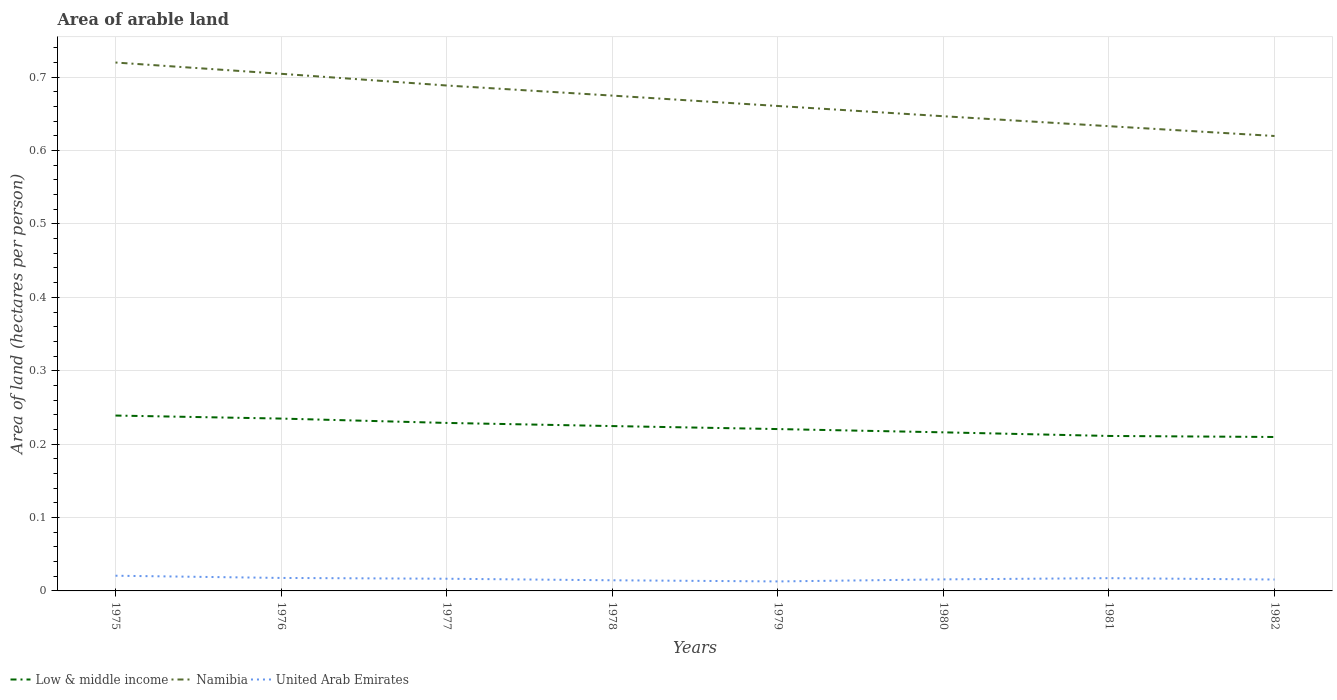How many different coloured lines are there?
Make the answer very short. 3. Does the line corresponding to Low & middle income intersect with the line corresponding to Namibia?
Offer a terse response. No. Is the number of lines equal to the number of legend labels?
Ensure brevity in your answer.  Yes. Across all years, what is the maximum total arable land in United Arab Emirates?
Your response must be concise. 0.01. In which year was the total arable land in Namibia maximum?
Offer a terse response. 1982. What is the total total arable land in United Arab Emirates in the graph?
Ensure brevity in your answer.  0. What is the difference between the highest and the second highest total arable land in Namibia?
Keep it short and to the point. 0.1. What is the difference between the highest and the lowest total arable land in United Arab Emirates?
Keep it short and to the point. 4. Is the total arable land in Low & middle income strictly greater than the total arable land in United Arab Emirates over the years?
Offer a terse response. No. What is the difference between two consecutive major ticks on the Y-axis?
Provide a short and direct response. 0.1. Does the graph contain any zero values?
Provide a short and direct response. No. Does the graph contain grids?
Your answer should be compact. Yes. What is the title of the graph?
Provide a short and direct response. Area of arable land. What is the label or title of the Y-axis?
Keep it short and to the point. Area of land (hectares per person). What is the Area of land (hectares per person) in Low & middle income in 1975?
Your response must be concise. 0.24. What is the Area of land (hectares per person) of Namibia in 1975?
Your answer should be very brief. 0.72. What is the Area of land (hectares per person) of United Arab Emirates in 1975?
Provide a succinct answer. 0.02. What is the Area of land (hectares per person) of Low & middle income in 1976?
Provide a succinct answer. 0.23. What is the Area of land (hectares per person) in Namibia in 1976?
Your response must be concise. 0.7. What is the Area of land (hectares per person) in United Arab Emirates in 1976?
Ensure brevity in your answer.  0.02. What is the Area of land (hectares per person) of Low & middle income in 1977?
Your answer should be very brief. 0.23. What is the Area of land (hectares per person) of Namibia in 1977?
Ensure brevity in your answer.  0.69. What is the Area of land (hectares per person) in United Arab Emirates in 1977?
Keep it short and to the point. 0.02. What is the Area of land (hectares per person) of Low & middle income in 1978?
Your answer should be very brief. 0.22. What is the Area of land (hectares per person) in Namibia in 1978?
Your response must be concise. 0.67. What is the Area of land (hectares per person) in United Arab Emirates in 1978?
Make the answer very short. 0.01. What is the Area of land (hectares per person) of Low & middle income in 1979?
Keep it short and to the point. 0.22. What is the Area of land (hectares per person) of Namibia in 1979?
Your answer should be very brief. 0.66. What is the Area of land (hectares per person) in United Arab Emirates in 1979?
Your answer should be very brief. 0.01. What is the Area of land (hectares per person) in Low & middle income in 1980?
Your answer should be compact. 0.22. What is the Area of land (hectares per person) in Namibia in 1980?
Make the answer very short. 0.65. What is the Area of land (hectares per person) of United Arab Emirates in 1980?
Your answer should be very brief. 0.02. What is the Area of land (hectares per person) of Low & middle income in 1981?
Keep it short and to the point. 0.21. What is the Area of land (hectares per person) in Namibia in 1981?
Offer a terse response. 0.63. What is the Area of land (hectares per person) in United Arab Emirates in 1981?
Ensure brevity in your answer.  0.02. What is the Area of land (hectares per person) of Low & middle income in 1982?
Make the answer very short. 0.21. What is the Area of land (hectares per person) in Namibia in 1982?
Your answer should be very brief. 0.62. What is the Area of land (hectares per person) in United Arab Emirates in 1982?
Make the answer very short. 0.02. Across all years, what is the maximum Area of land (hectares per person) in Low & middle income?
Your answer should be very brief. 0.24. Across all years, what is the maximum Area of land (hectares per person) of Namibia?
Make the answer very short. 0.72. Across all years, what is the maximum Area of land (hectares per person) in United Arab Emirates?
Your answer should be compact. 0.02. Across all years, what is the minimum Area of land (hectares per person) of Low & middle income?
Offer a very short reply. 0.21. Across all years, what is the minimum Area of land (hectares per person) of Namibia?
Ensure brevity in your answer.  0.62. Across all years, what is the minimum Area of land (hectares per person) of United Arab Emirates?
Offer a very short reply. 0.01. What is the total Area of land (hectares per person) in Low & middle income in the graph?
Ensure brevity in your answer.  1.78. What is the total Area of land (hectares per person) in Namibia in the graph?
Offer a terse response. 5.35. What is the total Area of land (hectares per person) of United Arab Emirates in the graph?
Ensure brevity in your answer.  0.13. What is the difference between the Area of land (hectares per person) in Low & middle income in 1975 and that in 1976?
Make the answer very short. 0. What is the difference between the Area of land (hectares per person) in Namibia in 1975 and that in 1976?
Your answer should be compact. 0.02. What is the difference between the Area of land (hectares per person) in United Arab Emirates in 1975 and that in 1976?
Offer a very short reply. 0. What is the difference between the Area of land (hectares per person) in Low & middle income in 1975 and that in 1977?
Your answer should be compact. 0.01. What is the difference between the Area of land (hectares per person) of Namibia in 1975 and that in 1977?
Keep it short and to the point. 0.03. What is the difference between the Area of land (hectares per person) in United Arab Emirates in 1975 and that in 1977?
Ensure brevity in your answer.  0. What is the difference between the Area of land (hectares per person) of Low & middle income in 1975 and that in 1978?
Your answer should be very brief. 0.01. What is the difference between the Area of land (hectares per person) in Namibia in 1975 and that in 1978?
Give a very brief answer. 0.05. What is the difference between the Area of land (hectares per person) of United Arab Emirates in 1975 and that in 1978?
Offer a very short reply. 0.01. What is the difference between the Area of land (hectares per person) in Low & middle income in 1975 and that in 1979?
Provide a short and direct response. 0.02. What is the difference between the Area of land (hectares per person) in Namibia in 1975 and that in 1979?
Ensure brevity in your answer.  0.06. What is the difference between the Area of land (hectares per person) of United Arab Emirates in 1975 and that in 1979?
Offer a very short reply. 0.01. What is the difference between the Area of land (hectares per person) in Low & middle income in 1975 and that in 1980?
Provide a short and direct response. 0.02. What is the difference between the Area of land (hectares per person) of Namibia in 1975 and that in 1980?
Provide a short and direct response. 0.07. What is the difference between the Area of land (hectares per person) in United Arab Emirates in 1975 and that in 1980?
Provide a short and direct response. 0.01. What is the difference between the Area of land (hectares per person) of Low & middle income in 1975 and that in 1981?
Make the answer very short. 0.03. What is the difference between the Area of land (hectares per person) in Namibia in 1975 and that in 1981?
Keep it short and to the point. 0.09. What is the difference between the Area of land (hectares per person) of United Arab Emirates in 1975 and that in 1981?
Offer a terse response. 0. What is the difference between the Area of land (hectares per person) in Low & middle income in 1975 and that in 1982?
Provide a short and direct response. 0.03. What is the difference between the Area of land (hectares per person) in Namibia in 1975 and that in 1982?
Give a very brief answer. 0.1. What is the difference between the Area of land (hectares per person) of United Arab Emirates in 1975 and that in 1982?
Provide a short and direct response. 0.01. What is the difference between the Area of land (hectares per person) of Low & middle income in 1976 and that in 1977?
Provide a short and direct response. 0.01. What is the difference between the Area of land (hectares per person) in Namibia in 1976 and that in 1977?
Ensure brevity in your answer.  0.02. What is the difference between the Area of land (hectares per person) of United Arab Emirates in 1976 and that in 1977?
Provide a succinct answer. 0. What is the difference between the Area of land (hectares per person) in Low & middle income in 1976 and that in 1978?
Offer a very short reply. 0.01. What is the difference between the Area of land (hectares per person) in Namibia in 1976 and that in 1978?
Keep it short and to the point. 0.03. What is the difference between the Area of land (hectares per person) of United Arab Emirates in 1976 and that in 1978?
Ensure brevity in your answer.  0. What is the difference between the Area of land (hectares per person) in Low & middle income in 1976 and that in 1979?
Keep it short and to the point. 0.01. What is the difference between the Area of land (hectares per person) in Namibia in 1976 and that in 1979?
Provide a succinct answer. 0.04. What is the difference between the Area of land (hectares per person) of United Arab Emirates in 1976 and that in 1979?
Offer a very short reply. 0. What is the difference between the Area of land (hectares per person) in Low & middle income in 1976 and that in 1980?
Your answer should be compact. 0.02. What is the difference between the Area of land (hectares per person) in Namibia in 1976 and that in 1980?
Your answer should be compact. 0.06. What is the difference between the Area of land (hectares per person) in United Arab Emirates in 1976 and that in 1980?
Ensure brevity in your answer.  0. What is the difference between the Area of land (hectares per person) of Low & middle income in 1976 and that in 1981?
Offer a terse response. 0.02. What is the difference between the Area of land (hectares per person) of Namibia in 1976 and that in 1981?
Make the answer very short. 0.07. What is the difference between the Area of land (hectares per person) of Low & middle income in 1976 and that in 1982?
Offer a very short reply. 0.03. What is the difference between the Area of land (hectares per person) of Namibia in 1976 and that in 1982?
Ensure brevity in your answer.  0.08. What is the difference between the Area of land (hectares per person) in United Arab Emirates in 1976 and that in 1982?
Make the answer very short. 0. What is the difference between the Area of land (hectares per person) of Low & middle income in 1977 and that in 1978?
Your response must be concise. 0. What is the difference between the Area of land (hectares per person) in Namibia in 1977 and that in 1978?
Offer a very short reply. 0.01. What is the difference between the Area of land (hectares per person) of United Arab Emirates in 1977 and that in 1978?
Your answer should be compact. 0. What is the difference between the Area of land (hectares per person) in Low & middle income in 1977 and that in 1979?
Your answer should be compact. 0.01. What is the difference between the Area of land (hectares per person) of Namibia in 1977 and that in 1979?
Your response must be concise. 0.03. What is the difference between the Area of land (hectares per person) of United Arab Emirates in 1977 and that in 1979?
Make the answer very short. 0. What is the difference between the Area of land (hectares per person) in Low & middle income in 1977 and that in 1980?
Your answer should be compact. 0.01. What is the difference between the Area of land (hectares per person) of Namibia in 1977 and that in 1980?
Your answer should be compact. 0.04. What is the difference between the Area of land (hectares per person) of United Arab Emirates in 1977 and that in 1980?
Provide a short and direct response. 0. What is the difference between the Area of land (hectares per person) of Low & middle income in 1977 and that in 1981?
Your response must be concise. 0.02. What is the difference between the Area of land (hectares per person) in Namibia in 1977 and that in 1981?
Your response must be concise. 0.06. What is the difference between the Area of land (hectares per person) in United Arab Emirates in 1977 and that in 1981?
Keep it short and to the point. -0. What is the difference between the Area of land (hectares per person) in Low & middle income in 1977 and that in 1982?
Ensure brevity in your answer.  0.02. What is the difference between the Area of land (hectares per person) of Namibia in 1977 and that in 1982?
Your answer should be very brief. 0.07. What is the difference between the Area of land (hectares per person) in United Arab Emirates in 1977 and that in 1982?
Your answer should be very brief. 0. What is the difference between the Area of land (hectares per person) in Low & middle income in 1978 and that in 1979?
Your response must be concise. 0. What is the difference between the Area of land (hectares per person) of Namibia in 1978 and that in 1979?
Your answer should be compact. 0.01. What is the difference between the Area of land (hectares per person) of United Arab Emirates in 1978 and that in 1979?
Make the answer very short. 0. What is the difference between the Area of land (hectares per person) of Low & middle income in 1978 and that in 1980?
Your response must be concise. 0.01. What is the difference between the Area of land (hectares per person) in Namibia in 1978 and that in 1980?
Ensure brevity in your answer.  0.03. What is the difference between the Area of land (hectares per person) in United Arab Emirates in 1978 and that in 1980?
Offer a very short reply. -0. What is the difference between the Area of land (hectares per person) of Low & middle income in 1978 and that in 1981?
Your answer should be compact. 0.01. What is the difference between the Area of land (hectares per person) in Namibia in 1978 and that in 1981?
Keep it short and to the point. 0.04. What is the difference between the Area of land (hectares per person) in United Arab Emirates in 1978 and that in 1981?
Provide a short and direct response. -0. What is the difference between the Area of land (hectares per person) of Low & middle income in 1978 and that in 1982?
Provide a succinct answer. 0.01. What is the difference between the Area of land (hectares per person) in Namibia in 1978 and that in 1982?
Your answer should be compact. 0.06. What is the difference between the Area of land (hectares per person) in United Arab Emirates in 1978 and that in 1982?
Ensure brevity in your answer.  -0. What is the difference between the Area of land (hectares per person) of Low & middle income in 1979 and that in 1980?
Give a very brief answer. 0. What is the difference between the Area of land (hectares per person) of Namibia in 1979 and that in 1980?
Ensure brevity in your answer.  0.01. What is the difference between the Area of land (hectares per person) in United Arab Emirates in 1979 and that in 1980?
Your answer should be very brief. -0. What is the difference between the Area of land (hectares per person) in Low & middle income in 1979 and that in 1981?
Ensure brevity in your answer.  0.01. What is the difference between the Area of land (hectares per person) of Namibia in 1979 and that in 1981?
Provide a succinct answer. 0.03. What is the difference between the Area of land (hectares per person) in United Arab Emirates in 1979 and that in 1981?
Offer a very short reply. -0. What is the difference between the Area of land (hectares per person) of Low & middle income in 1979 and that in 1982?
Offer a very short reply. 0.01. What is the difference between the Area of land (hectares per person) of Namibia in 1979 and that in 1982?
Your answer should be very brief. 0.04. What is the difference between the Area of land (hectares per person) in United Arab Emirates in 1979 and that in 1982?
Offer a very short reply. -0. What is the difference between the Area of land (hectares per person) in Low & middle income in 1980 and that in 1981?
Your answer should be very brief. 0. What is the difference between the Area of land (hectares per person) of Namibia in 1980 and that in 1981?
Offer a terse response. 0.01. What is the difference between the Area of land (hectares per person) in United Arab Emirates in 1980 and that in 1981?
Ensure brevity in your answer.  -0. What is the difference between the Area of land (hectares per person) in Low & middle income in 1980 and that in 1982?
Ensure brevity in your answer.  0.01. What is the difference between the Area of land (hectares per person) in Namibia in 1980 and that in 1982?
Your answer should be compact. 0.03. What is the difference between the Area of land (hectares per person) in Low & middle income in 1981 and that in 1982?
Provide a short and direct response. 0. What is the difference between the Area of land (hectares per person) in Namibia in 1981 and that in 1982?
Provide a short and direct response. 0.01. What is the difference between the Area of land (hectares per person) in United Arab Emirates in 1981 and that in 1982?
Keep it short and to the point. 0. What is the difference between the Area of land (hectares per person) in Low & middle income in 1975 and the Area of land (hectares per person) in Namibia in 1976?
Your answer should be compact. -0.47. What is the difference between the Area of land (hectares per person) of Low & middle income in 1975 and the Area of land (hectares per person) of United Arab Emirates in 1976?
Your answer should be very brief. 0.22. What is the difference between the Area of land (hectares per person) of Namibia in 1975 and the Area of land (hectares per person) of United Arab Emirates in 1976?
Ensure brevity in your answer.  0.7. What is the difference between the Area of land (hectares per person) of Low & middle income in 1975 and the Area of land (hectares per person) of Namibia in 1977?
Your answer should be compact. -0.45. What is the difference between the Area of land (hectares per person) in Low & middle income in 1975 and the Area of land (hectares per person) in United Arab Emirates in 1977?
Offer a very short reply. 0.22. What is the difference between the Area of land (hectares per person) in Namibia in 1975 and the Area of land (hectares per person) in United Arab Emirates in 1977?
Make the answer very short. 0.7. What is the difference between the Area of land (hectares per person) of Low & middle income in 1975 and the Area of land (hectares per person) of Namibia in 1978?
Give a very brief answer. -0.44. What is the difference between the Area of land (hectares per person) of Low & middle income in 1975 and the Area of land (hectares per person) of United Arab Emirates in 1978?
Your response must be concise. 0.22. What is the difference between the Area of land (hectares per person) in Namibia in 1975 and the Area of land (hectares per person) in United Arab Emirates in 1978?
Your answer should be very brief. 0.71. What is the difference between the Area of land (hectares per person) in Low & middle income in 1975 and the Area of land (hectares per person) in Namibia in 1979?
Your answer should be very brief. -0.42. What is the difference between the Area of land (hectares per person) in Low & middle income in 1975 and the Area of land (hectares per person) in United Arab Emirates in 1979?
Your answer should be compact. 0.23. What is the difference between the Area of land (hectares per person) of Namibia in 1975 and the Area of land (hectares per person) of United Arab Emirates in 1979?
Provide a succinct answer. 0.71. What is the difference between the Area of land (hectares per person) of Low & middle income in 1975 and the Area of land (hectares per person) of Namibia in 1980?
Provide a succinct answer. -0.41. What is the difference between the Area of land (hectares per person) of Low & middle income in 1975 and the Area of land (hectares per person) of United Arab Emirates in 1980?
Offer a very short reply. 0.22. What is the difference between the Area of land (hectares per person) of Namibia in 1975 and the Area of land (hectares per person) of United Arab Emirates in 1980?
Make the answer very short. 0.7. What is the difference between the Area of land (hectares per person) of Low & middle income in 1975 and the Area of land (hectares per person) of Namibia in 1981?
Your answer should be very brief. -0.39. What is the difference between the Area of land (hectares per person) in Low & middle income in 1975 and the Area of land (hectares per person) in United Arab Emirates in 1981?
Offer a very short reply. 0.22. What is the difference between the Area of land (hectares per person) of Namibia in 1975 and the Area of land (hectares per person) of United Arab Emirates in 1981?
Give a very brief answer. 0.7. What is the difference between the Area of land (hectares per person) in Low & middle income in 1975 and the Area of land (hectares per person) in Namibia in 1982?
Provide a succinct answer. -0.38. What is the difference between the Area of land (hectares per person) of Low & middle income in 1975 and the Area of land (hectares per person) of United Arab Emirates in 1982?
Your answer should be compact. 0.22. What is the difference between the Area of land (hectares per person) of Namibia in 1975 and the Area of land (hectares per person) of United Arab Emirates in 1982?
Your answer should be very brief. 0.7. What is the difference between the Area of land (hectares per person) in Low & middle income in 1976 and the Area of land (hectares per person) in Namibia in 1977?
Your answer should be very brief. -0.45. What is the difference between the Area of land (hectares per person) of Low & middle income in 1976 and the Area of land (hectares per person) of United Arab Emirates in 1977?
Your answer should be compact. 0.22. What is the difference between the Area of land (hectares per person) in Namibia in 1976 and the Area of land (hectares per person) in United Arab Emirates in 1977?
Give a very brief answer. 0.69. What is the difference between the Area of land (hectares per person) in Low & middle income in 1976 and the Area of land (hectares per person) in Namibia in 1978?
Your answer should be very brief. -0.44. What is the difference between the Area of land (hectares per person) of Low & middle income in 1976 and the Area of land (hectares per person) of United Arab Emirates in 1978?
Offer a terse response. 0.22. What is the difference between the Area of land (hectares per person) in Namibia in 1976 and the Area of land (hectares per person) in United Arab Emirates in 1978?
Keep it short and to the point. 0.69. What is the difference between the Area of land (hectares per person) in Low & middle income in 1976 and the Area of land (hectares per person) in Namibia in 1979?
Offer a terse response. -0.43. What is the difference between the Area of land (hectares per person) in Low & middle income in 1976 and the Area of land (hectares per person) in United Arab Emirates in 1979?
Your response must be concise. 0.22. What is the difference between the Area of land (hectares per person) of Namibia in 1976 and the Area of land (hectares per person) of United Arab Emirates in 1979?
Keep it short and to the point. 0.69. What is the difference between the Area of land (hectares per person) in Low & middle income in 1976 and the Area of land (hectares per person) in Namibia in 1980?
Offer a terse response. -0.41. What is the difference between the Area of land (hectares per person) in Low & middle income in 1976 and the Area of land (hectares per person) in United Arab Emirates in 1980?
Offer a terse response. 0.22. What is the difference between the Area of land (hectares per person) in Namibia in 1976 and the Area of land (hectares per person) in United Arab Emirates in 1980?
Ensure brevity in your answer.  0.69. What is the difference between the Area of land (hectares per person) of Low & middle income in 1976 and the Area of land (hectares per person) of Namibia in 1981?
Your answer should be compact. -0.4. What is the difference between the Area of land (hectares per person) in Low & middle income in 1976 and the Area of land (hectares per person) in United Arab Emirates in 1981?
Give a very brief answer. 0.22. What is the difference between the Area of land (hectares per person) in Namibia in 1976 and the Area of land (hectares per person) in United Arab Emirates in 1981?
Give a very brief answer. 0.69. What is the difference between the Area of land (hectares per person) of Low & middle income in 1976 and the Area of land (hectares per person) of Namibia in 1982?
Your response must be concise. -0.39. What is the difference between the Area of land (hectares per person) in Low & middle income in 1976 and the Area of land (hectares per person) in United Arab Emirates in 1982?
Your answer should be compact. 0.22. What is the difference between the Area of land (hectares per person) of Namibia in 1976 and the Area of land (hectares per person) of United Arab Emirates in 1982?
Offer a terse response. 0.69. What is the difference between the Area of land (hectares per person) of Low & middle income in 1977 and the Area of land (hectares per person) of Namibia in 1978?
Keep it short and to the point. -0.45. What is the difference between the Area of land (hectares per person) of Low & middle income in 1977 and the Area of land (hectares per person) of United Arab Emirates in 1978?
Provide a succinct answer. 0.21. What is the difference between the Area of land (hectares per person) of Namibia in 1977 and the Area of land (hectares per person) of United Arab Emirates in 1978?
Ensure brevity in your answer.  0.67. What is the difference between the Area of land (hectares per person) of Low & middle income in 1977 and the Area of land (hectares per person) of Namibia in 1979?
Give a very brief answer. -0.43. What is the difference between the Area of land (hectares per person) of Low & middle income in 1977 and the Area of land (hectares per person) of United Arab Emirates in 1979?
Offer a terse response. 0.22. What is the difference between the Area of land (hectares per person) of Namibia in 1977 and the Area of land (hectares per person) of United Arab Emirates in 1979?
Ensure brevity in your answer.  0.68. What is the difference between the Area of land (hectares per person) in Low & middle income in 1977 and the Area of land (hectares per person) in Namibia in 1980?
Offer a very short reply. -0.42. What is the difference between the Area of land (hectares per person) in Low & middle income in 1977 and the Area of land (hectares per person) in United Arab Emirates in 1980?
Your response must be concise. 0.21. What is the difference between the Area of land (hectares per person) of Namibia in 1977 and the Area of land (hectares per person) of United Arab Emirates in 1980?
Your response must be concise. 0.67. What is the difference between the Area of land (hectares per person) of Low & middle income in 1977 and the Area of land (hectares per person) of Namibia in 1981?
Offer a very short reply. -0.4. What is the difference between the Area of land (hectares per person) in Low & middle income in 1977 and the Area of land (hectares per person) in United Arab Emirates in 1981?
Provide a succinct answer. 0.21. What is the difference between the Area of land (hectares per person) of Namibia in 1977 and the Area of land (hectares per person) of United Arab Emirates in 1981?
Offer a terse response. 0.67. What is the difference between the Area of land (hectares per person) in Low & middle income in 1977 and the Area of land (hectares per person) in Namibia in 1982?
Provide a succinct answer. -0.39. What is the difference between the Area of land (hectares per person) of Low & middle income in 1977 and the Area of land (hectares per person) of United Arab Emirates in 1982?
Give a very brief answer. 0.21. What is the difference between the Area of land (hectares per person) in Namibia in 1977 and the Area of land (hectares per person) in United Arab Emirates in 1982?
Give a very brief answer. 0.67. What is the difference between the Area of land (hectares per person) in Low & middle income in 1978 and the Area of land (hectares per person) in Namibia in 1979?
Make the answer very short. -0.44. What is the difference between the Area of land (hectares per person) of Low & middle income in 1978 and the Area of land (hectares per person) of United Arab Emirates in 1979?
Make the answer very short. 0.21. What is the difference between the Area of land (hectares per person) of Namibia in 1978 and the Area of land (hectares per person) of United Arab Emirates in 1979?
Make the answer very short. 0.66. What is the difference between the Area of land (hectares per person) in Low & middle income in 1978 and the Area of land (hectares per person) in Namibia in 1980?
Your answer should be compact. -0.42. What is the difference between the Area of land (hectares per person) in Low & middle income in 1978 and the Area of land (hectares per person) in United Arab Emirates in 1980?
Offer a very short reply. 0.21. What is the difference between the Area of land (hectares per person) of Namibia in 1978 and the Area of land (hectares per person) of United Arab Emirates in 1980?
Your response must be concise. 0.66. What is the difference between the Area of land (hectares per person) of Low & middle income in 1978 and the Area of land (hectares per person) of Namibia in 1981?
Your answer should be compact. -0.41. What is the difference between the Area of land (hectares per person) of Low & middle income in 1978 and the Area of land (hectares per person) of United Arab Emirates in 1981?
Ensure brevity in your answer.  0.21. What is the difference between the Area of land (hectares per person) in Namibia in 1978 and the Area of land (hectares per person) in United Arab Emirates in 1981?
Keep it short and to the point. 0.66. What is the difference between the Area of land (hectares per person) of Low & middle income in 1978 and the Area of land (hectares per person) of Namibia in 1982?
Your answer should be compact. -0.4. What is the difference between the Area of land (hectares per person) in Low & middle income in 1978 and the Area of land (hectares per person) in United Arab Emirates in 1982?
Provide a short and direct response. 0.21. What is the difference between the Area of land (hectares per person) in Namibia in 1978 and the Area of land (hectares per person) in United Arab Emirates in 1982?
Offer a terse response. 0.66. What is the difference between the Area of land (hectares per person) in Low & middle income in 1979 and the Area of land (hectares per person) in Namibia in 1980?
Your response must be concise. -0.43. What is the difference between the Area of land (hectares per person) of Low & middle income in 1979 and the Area of land (hectares per person) of United Arab Emirates in 1980?
Offer a very short reply. 0.2. What is the difference between the Area of land (hectares per person) of Namibia in 1979 and the Area of land (hectares per person) of United Arab Emirates in 1980?
Keep it short and to the point. 0.65. What is the difference between the Area of land (hectares per person) in Low & middle income in 1979 and the Area of land (hectares per person) in Namibia in 1981?
Your response must be concise. -0.41. What is the difference between the Area of land (hectares per person) of Low & middle income in 1979 and the Area of land (hectares per person) of United Arab Emirates in 1981?
Keep it short and to the point. 0.2. What is the difference between the Area of land (hectares per person) in Namibia in 1979 and the Area of land (hectares per person) in United Arab Emirates in 1981?
Your answer should be very brief. 0.64. What is the difference between the Area of land (hectares per person) of Low & middle income in 1979 and the Area of land (hectares per person) of Namibia in 1982?
Offer a terse response. -0.4. What is the difference between the Area of land (hectares per person) of Low & middle income in 1979 and the Area of land (hectares per person) of United Arab Emirates in 1982?
Give a very brief answer. 0.2. What is the difference between the Area of land (hectares per person) of Namibia in 1979 and the Area of land (hectares per person) of United Arab Emirates in 1982?
Your response must be concise. 0.65. What is the difference between the Area of land (hectares per person) in Low & middle income in 1980 and the Area of land (hectares per person) in Namibia in 1981?
Give a very brief answer. -0.42. What is the difference between the Area of land (hectares per person) of Low & middle income in 1980 and the Area of land (hectares per person) of United Arab Emirates in 1981?
Offer a terse response. 0.2. What is the difference between the Area of land (hectares per person) in Namibia in 1980 and the Area of land (hectares per person) in United Arab Emirates in 1981?
Provide a succinct answer. 0.63. What is the difference between the Area of land (hectares per person) in Low & middle income in 1980 and the Area of land (hectares per person) in Namibia in 1982?
Offer a very short reply. -0.4. What is the difference between the Area of land (hectares per person) of Low & middle income in 1980 and the Area of land (hectares per person) of United Arab Emirates in 1982?
Offer a terse response. 0.2. What is the difference between the Area of land (hectares per person) of Namibia in 1980 and the Area of land (hectares per person) of United Arab Emirates in 1982?
Offer a very short reply. 0.63. What is the difference between the Area of land (hectares per person) in Low & middle income in 1981 and the Area of land (hectares per person) in Namibia in 1982?
Offer a terse response. -0.41. What is the difference between the Area of land (hectares per person) of Low & middle income in 1981 and the Area of land (hectares per person) of United Arab Emirates in 1982?
Your answer should be very brief. 0.2. What is the difference between the Area of land (hectares per person) of Namibia in 1981 and the Area of land (hectares per person) of United Arab Emirates in 1982?
Make the answer very short. 0.62. What is the average Area of land (hectares per person) in Low & middle income per year?
Your answer should be compact. 0.22. What is the average Area of land (hectares per person) of Namibia per year?
Make the answer very short. 0.67. What is the average Area of land (hectares per person) of United Arab Emirates per year?
Offer a very short reply. 0.02. In the year 1975, what is the difference between the Area of land (hectares per person) in Low & middle income and Area of land (hectares per person) in Namibia?
Offer a terse response. -0.48. In the year 1975, what is the difference between the Area of land (hectares per person) of Low & middle income and Area of land (hectares per person) of United Arab Emirates?
Your answer should be very brief. 0.22. In the year 1975, what is the difference between the Area of land (hectares per person) of Namibia and Area of land (hectares per person) of United Arab Emirates?
Make the answer very short. 0.7. In the year 1976, what is the difference between the Area of land (hectares per person) in Low & middle income and Area of land (hectares per person) in Namibia?
Make the answer very short. -0.47. In the year 1976, what is the difference between the Area of land (hectares per person) in Low & middle income and Area of land (hectares per person) in United Arab Emirates?
Your response must be concise. 0.22. In the year 1976, what is the difference between the Area of land (hectares per person) in Namibia and Area of land (hectares per person) in United Arab Emirates?
Your answer should be compact. 0.69. In the year 1977, what is the difference between the Area of land (hectares per person) of Low & middle income and Area of land (hectares per person) of Namibia?
Your response must be concise. -0.46. In the year 1977, what is the difference between the Area of land (hectares per person) of Low & middle income and Area of land (hectares per person) of United Arab Emirates?
Keep it short and to the point. 0.21. In the year 1977, what is the difference between the Area of land (hectares per person) of Namibia and Area of land (hectares per person) of United Arab Emirates?
Your response must be concise. 0.67. In the year 1978, what is the difference between the Area of land (hectares per person) in Low & middle income and Area of land (hectares per person) in Namibia?
Your response must be concise. -0.45. In the year 1978, what is the difference between the Area of land (hectares per person) of Low & middle income and Area of land (hectares per person) of United Arab Emirates?
Keep it short and to the point. 0.21. In the year 1978, what is the difference between the Area of land (hectares per person) of Namibia and Area of land (hectares per person) of United Arab Emirates?
Your answer should be very brief. 0.66. In the year 1979, what is the difference between the Area of land (hectares per person) in Low & middle income and Area of land (hectares per person) in Namibia?
Give a very brief answer. -0.44. In the year 1979, what is the difference between the Area of land (hectares per person) of Low & middle income and Area of land (hectares per person) of United Arab Emirates?
Your response must be concise. 0.21. In the year 1979, what is the difference between the Area of land (hectares per person) in Namibia and Area of land (hectares per person) in United Arab Emirates?
Your answer should be very brief. 0.65. In the year 1980, what is the difference between the Area of land (hectares per person) in Low & middle income and Area of land (hectares per person) in Namibia?
Ensure brevity in your answer.  -0.43. In the year 1980, what is the difference between the Area of land (hectares per person) of Low & middle income and Area of land (hectares per person) of United Arab Emirates?
Offer a very short reply. 0.2. In the year 1980, what is the difference between the Area of land (hectares per person) of Namibia and Area of land (hectares per person) of United Arab Emirates?
Make the answer very short. 0.63. In the year 1981, what is the difference between the Area of land (hectares per person) in Low & middle income and Area of land (hectares per person) in Namibia?
Ensure brevity in your answer.  -0.42. In the year 1981, what is the difference between the Area of land (hectares per person) in Low & middle income and Area of land (hectares per person) in United Arab Emirates?
Keep it short and to the point. 0.19. In the year 1981, what is the difference between the Area of land (hectares per person) in Namibia and Area of land (hectares per person) in United Arab Emirates?
Your answer should be very brief. 0.62. In the year 1982, what is the difference between the Area of land (hectares per person) in Low & middle income and Area of land (hectares per person) in Namibia?
Keep it short and to the point. -0.41. In the year 1982, what is the difference between the Area of land (hectares per person) of Low & middle income and Area of land (hectares per person) of United Arab Emirates?
Your answer should be compact. 0.19. In the year 1982, what is the difference between the Area of land (hectares per person) in Namibia and Area of land (hectares per person) in United Arab Emirates?
Make the answer very short. 0.6. What is the ratio of the Area of land (hectares per person) of Low & middle income in 1975 to that in 1976?
Make the answer very short. 1.02. What is the ratio of the Area of land (hectares per person) in Namibia in 1975 to that in 1976?
Provide a succinct answer. 1.02. What is the ratio of the Area of land (hectares per person) of United Arab Emirates in 1975 to that in 1976?
Offer a very short reply. 1.17. What is the ratio of the Area of land (hectares per person) in Low & middle income in 1975 to that in 1977?
Offer a very short reply. 1.04. What is the ratio of the Area of land (hectares per person) of Namibia in 1975 to that in 1977?
Provide a succinct answer. 1.05. What is the ratio of the Area of land (hectares per person) of United Arab Emirates in 1975 to that in 1977?
Give a very brief answer. 1.25. What is the ratio of the Area of land (hectares per person) in Low & middle income in 1975 to that in 1978?
Keep it short and to the point. 1.06. What is the ratio of the Area of land (hectares per person) in Namibia in 1975 to that in 1978?
Offer a very short reply. 1.07. What is the ratio of the Area of land (hectares per person) of United Arab Emirates in 1975 to that in 1978?
Ensure brevity in your answer.  1.43. What is the ratio of the Area of land (hectares per person) in Low & middle income in 1975 to that in 1979?
Your response must be concise. 1.08. What is the ratio of the Area of land (hectares per person) in Namibia in 1975 to that in 1979?
Your response must be concise. 1.09. What is the ratio of the Area of land (hectares per person) of Low & middle income in 1975 to that in 1980?
Your answer should be very brief. 1.11. What is the ratio of the Area of land (hectares per person) in Namibia in 1975 to that in 1980?
Give a very brief answer. 1.11. What is the ratio of the Area of land (hectares per person) of United Arab Emirates in 1975 to that in 1980?
Keep it short and to the point. 1.32. What is the ratio of the Area of land (hectares per person) in Low & middle income in 1975 to that in 1981?
Keep it short and to the point. 1.13. What is the ratio of the Area of land (hectares per person) of Namibia in 1975 to that in 1981?
Offer a terse response. 1.14. What is the ratio of the Area of land (hectares per person) of United Arab Emirates in 1975 to that in 1981?
Offer a very short reply. 1.19. What is the ratio of the Area of land (hectares per person) in Low & middle income in 1975 to that in 1982?
Ensure brevity in your answer.  1.14. What is the ratio of the Area of land (hectares per person) in Namibia in 1975 to that in 1982?
Keep it short and to the point. 1.16. What is the ratio of the Area of land (hectares per person) of United Arab Emirates in 1975 to that in 1982?
Make the answer very short. 1.33. What is the ratio of the Area of land (hectares per person) in Low & middle income in 1976 to that in 1977?
Keep it short and to the point. 1.03. What is the ratio of the Area of land (hectares per person) in Namibia in 1976 to that in 1977?
Offer a terse response. 1.02. What is the ratio of the Area of land (hectares per person) in United Arab Emirates in 1976 to that in 1977?
Offer a very short reply. 1.07. What is the ratio of the Area of land (hectares per person) in Low & middle income in 1976 to that in 1978?
Keep it short and to the point. 1.05. What is the ratio of the Area of land (hectares per person) in Namibia in 1976 to that in 1978?
Your response must be concise. 1.04. What is the ratio of the Area of land (hectares per person) in United Arab Emirates in 1976 to that in 1978?
Offer a terse response. 1.22. What is the ratio of the Area of land (hectares per person) in Low & middle income in 1976 to that in 1979?
Give a very brief answer. 1.06. What is the ratio of the Area of land (hectares per person) of Namibia in 1976 to that in 1979?
Provide a succinct answer. 1.07. What is the ratio of the Area of land (hectares per person) in United Arab Emirates in 1976 to that in 1979?
Your answer should be very brief. 1.37. What is the ratio of the Area of land (hectares per person) in Low & middle income in 1976 to that in 1980?
Your response must be concise. 1.09. What is the ratio of the Area of land (hectares per person) of Namibia in 1976 to that in 1980?
Ensure brevity in your answer.  1.09. What is the ratio of the Area of land (hectares per person) of United Arab Emirates in 1976 to that in 1980?
Offer a very short reply. 1.12. What is the ratio of the Area of land (hectares per person) in Low & middle income in 1976 to that in 1981?
Your answer should be compact. 1.11. What is the ratio of the Area of land (hectares per person) in Namibia in 1976 to that in 1981?
Provide a succinct answer. 1.11. What is the ratio of the Area of land (hectares per person) of United Arab Emirates in 1976 to that in 1981?
Offer a very short reply. 1.02. What is the ratio of the Area of land (hectares per person) of Low & middle income in 1976 to that in 1982?
Offer a terse response. 1.12. What is the ratio of the Area of land (hectares per person) in Namibia in 1976 to that in 1982?
Offer a very short reply. 1.14. What is the ratio of the Area of land (hectares per person) of United Arab Emirates in 1976 to that in 1982?
Keep it short and to the point. 1.14. What is the ratio of the Area of land (hectares per person) of Low & middle income in 1977 to that in 1978?
Keep it short and to the point. 1.02. What is the ratio of the Area of land (hectares per person) of Namibia in 1977 to that in 1978?
Offer a very short reply. 1.02. What is the ratio of the Area of land (hectares per person) of United Arab Emirates in 1977 to that in 1978?
Provide a short and direct response. 1.14. What is the ratio of the Area of land (hectares per person) in Low & middle income in 1977 to that in 1979?
Your answer should be very brief. 1.04. What is the ratio of the Area of land (hectares per person) of Namibia in 1977 to that in 1979?
Your answer should be very brief. 1.04. What is the ratio of the Area of land (hectares per person) in United Arab Emirates in 1977 to that in 1979?
Keep it short and to the point. 1.28. What is the ratio of the Area of land (hectares per person) in Low & middle income in 1977 to that in 1980?
Offer a terse response. 1.06. What is the ratio of the Area of land (hectares per person) of Namibia in 1977 to that in 1980?
Offer a terse response. 1.06. What is the ratio of the Area of land (hectares per person) of United Arab Emirates in 1977 to that in 1980?
Offer a very short reply. 1.05. What is the ratio of the Area of land (hectares per person) of Low & middle income in 1977 to that in 1981?
Keep it short and to the point. 1.08. What is the ratio of the Area of land (hectares per person) in Namibia in 1977 to that in 1981?
Your answer should be very brief. 1.09. What is the ratio of the Area of land (hectares per person) of United Arab Emirates in 1977 to that in 1981?
Give a very brief answer. 0.96. What is the ratio of the Area of land (hectares per person) in Low & middle income in 1977 to that in 1982?
Keep it short and to the point. 1.09. What is the ratio of the Area of land (hectares per person) of Namibia in 1977 to that in 1982?
Your response must be concise. 1.11. What is the ratio of the Area of land (hectares per person) of United Arab Emirates in 1977 to that in 1982?
Provide a short and direct response. 1.07. What is the ratio of the Area of land (hectares per person) of Low & middle income in 1978 to that in 1979?
Your response must be concise. 1.02. What is the ratio of the Area of land (hectares per person) of Namibia in 1978 to that in 1979?
Offer a terse response. 1.02. What is the ratio of the Area of land (hectares per person) of United Arab Emirates in 1978 to that in 1979?
Provide a succinct answer. 1.12. What is the ratio of the Area of land (hectares per person) in Low & middle income in 1978 to that in 1980?
Ensure brevity in your answer.  1.04. What is the ratio of the Area of land (hectares per person) of Namibia in 1978 to that in 1980?
Make the answer very short. 1.04. What is the ratio of the Area of land (hectares per person) in United Arab Emirates in 1978 to that in 1980?
Your answer should be compact. 0.92. What is the ratio of the Area of land (hectares per person) in Low & middle income in 1978 to that in 1981?
Ensure brevity in your answer.  1.06. What is the ratio of the Area of land (hectares per person) of Namibia in 1978 to that in 1981?
Make the answer very short. 1.07. What is the ratio of the Area of land (hectares per person) of United Arab Emirates in 1978 to that in 1981?
Keep it short and to the point. 0.83. What is the ratio of the Area of land (hectares per person) of Low & middle income in 1978 to that in 1982?
Your response must be concise. 1.07. What is the ratio of the Area of land (hectares per person) of Namibia in 1978 to that in 1982?
Offer a very short reply. 1.09. What is the ratio of the Area of land (hectares per person) in United Arab Emirates in 1978 to that in 1982?
Provide a short and direct response. 0.93. What is the ratio of the Area of land (hectares per person) of Low & middle income in 1979 to that in 1980?
Ensure brevity in your answer.  1.02. What is the ratio of the Area of land (hectares per person) of Namibia in 1979 to that in 1980?
Keep it short and to the point. 1.02. What is the ratio of the Area of land (hectares per person) in United Arab Emirates in 1979 to that in 1980?
Your response must be concise. 0.82. What is the ratio of the Area of land (hectares per person) of Low & middle income in 1979 to that in 1981?
Make the answer very short. 1.04. What is the ratio of the Area of land (hectares per person) in Namibia in 1979 to that in 1981?
Offer a very short reply. 1.04. What is the ratio of the Area of land (hectares per person) of United Arab Emirates in 1979 to that in 1981?
Keep it short and to the point. 0.74. What is the ratio of the Area of land (hectares per person) of Low & middle income in 1979 to that in 1982?
Offer a very short reply. 1.05. What is the ratio of the Area of land (hectares per person) of Namibia in 1979 to that in 1982?
Your answer should be compact. 1.07. What is the ratio of the Area of land (hectares per person) of United Arab Emirates in 1979 to that in 1982?
Keep it short and to the point. 0.83. What is the ratio of the Area of land (hectares per person) of Low & middle income in 1980 to that in 1981?
Keep it short and to the point. 1.02. What is the ratio of the Area of land (hectares per person) in Namibia in 1980 to that in 1981?
Provide a short and direct response. 1.02. What is the ratio of the Area of land (hectares per person) of United Arab Emirates in 1980 to that in 1981?
Your response must be concise. 0.91. What is the ratio of the Area of land (hectares per person) in Low & middle income in 1980 to that in 1982?
Offer a terse response. 1.03. What is the ratio of the Area of land (hectares per person) in Namibia in 1980 to that in 1982?
Offer a terse response. 1.04. What is the ratio of the Area of land (hectares per person) of United Arab Emirates in 1980 to that in 1982?
Offer a terse response. 1.01. What is the ratio of the Area of land (hectares per person) in Low & middle income in 1981 to that in 1982?
Your answer should be compact. 1.01. What is the ratio of the Area of land (hectares per person) in Namibia in 1981 to that in 1982?
Your answer should be compact. 1.02. What is the ratio of the Area of land (hectares per person) of United Arab Emirates in 1981 to that in 1982?
Ensure brevity in your answer.  1.12. What is the difference between the highest and the second highest Area of land (hectares per person) of Low & middle income?
Keep it short and to the point. 0. What is the difference between the highest and the second highest Area of land (hectares per person) of Namibia?
Offer a terse response. 0.02. What is the difference between the highest and the second highest Area of land (hectares per person) of United Arab Emirates?
Make the answer very short. 0. What is the difference between the highest and the lowest Area of land (hectares per person) in Low & middle income?
Provide a short and direct response. 0.03. What is the difference between the highest and the lowest Area of land (hectares per person) in Namibia?
Provide a succinct answer. 0.1. What is the difference between the highest and the lowest Area of land (hectares per person) of United Arab Emirates?
Your answer should be compact. 0.01. 